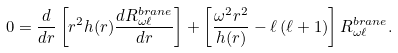<formula> <loc_0><loc_0><loc_500><loc_500>0 = \frac { d } { d r } \left [ r ^ { 2 } h ( r ) \frac { d R _ { \omega \ell } ^ { b r a n e } } { d r } \right ] + \left [ \frac { \omega ^ { 2 } r ^ { 2 } } { h ( r ) } - \ell \left ( \ell + 1 \right ) \right ] R _ { \omega \ell } ^ { b r a n e } .</formula> 